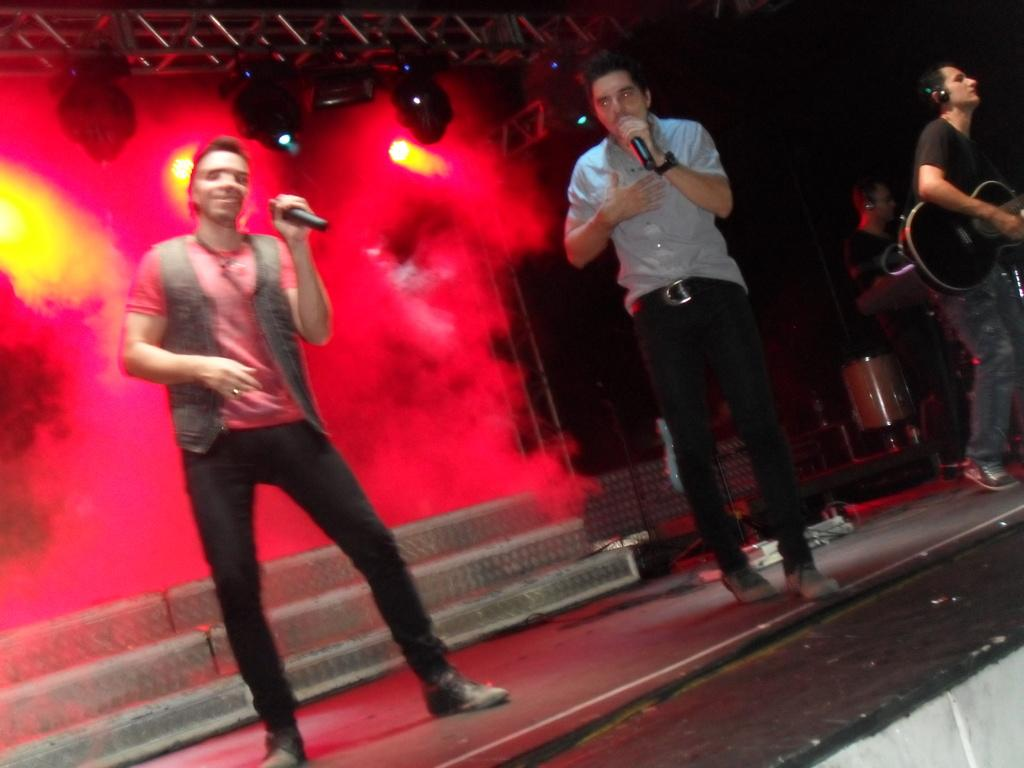What is happening on the stage in the image? There are people on the stage in the image. What are the people holding on the stage? Two people are holding microphones. What else can be seen in the image besides the people on stage? Musical instruments are present in the image. What can be seen in the background of the image? There are lights and other objects visible in the background of the image. How many houses can be seen in the image? There are no houses present in the image. What color is the eye of the person holding the microphone? There is no eye visible in the image, as it is focused on the people on stage and not on any individual's face. 